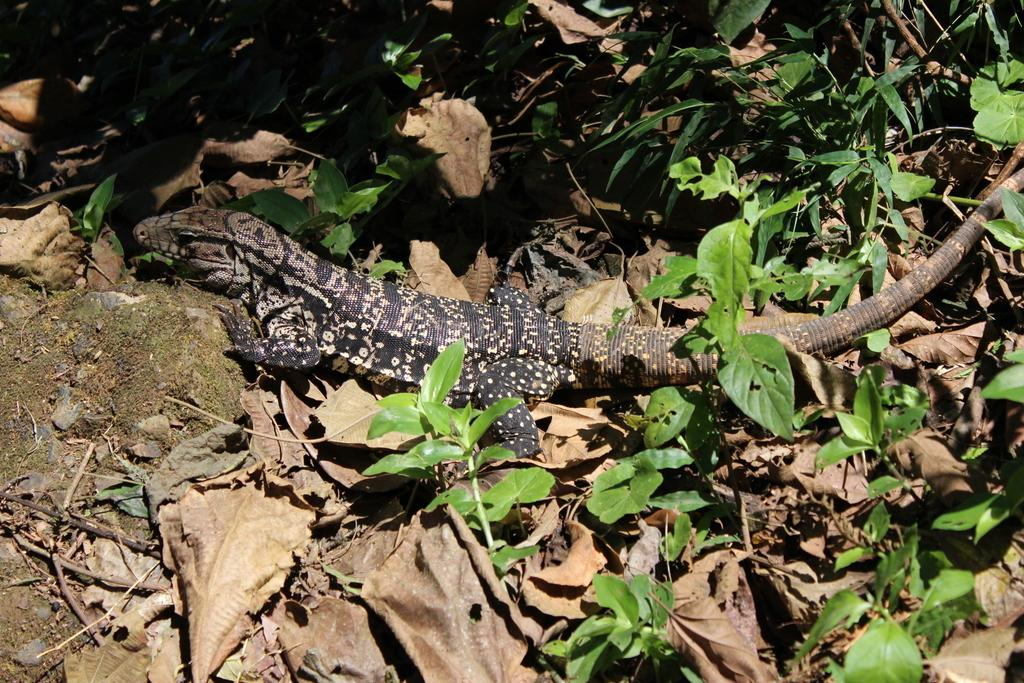What type of animal is present in the image? There is a reptile in the image. What can be seen in the background or surrounding the reptile? There are leaves in the image. What type of alarm can be heard going off in the image? There is no alarm present in the image, as it is a still image and cannot produce sound. 